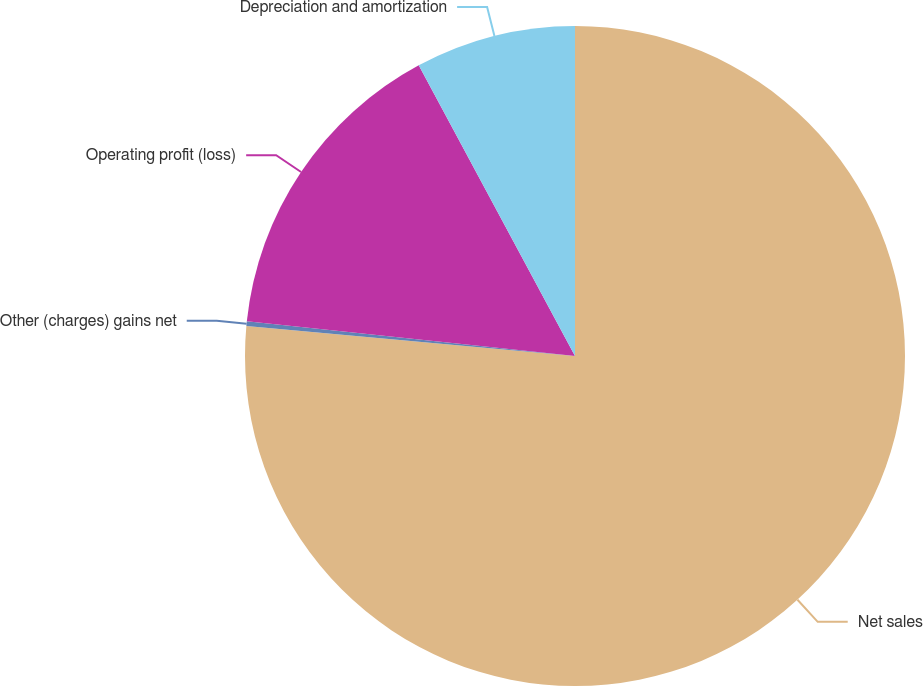<chart> <loc_0><loc_0><loc_500><loc_500><pie_chart><fcel>Net sales<fcel>Other (charges) gains net<fcel>Operating profit (loss)<fcel>Depreciation and amortization<nl><fcel>76.44%<fcel>0.23%<fcel>15.47%<fcel>7.85%<nl></chart> 